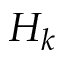Convert formula to latex. <formula><loc_0><loc_0><loc_500><loc_500>H _ { k }</formula> 